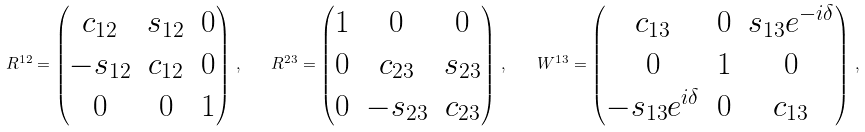Convert formula to latex. <formula><loc_0><loc_0><loc_500><loc_500>R ^ { 1 2 } = \begin{pmatrix} c _ { 1 2 } & s _ { 1 2 } & 0 \\ - s _ { 1 2 } & c _ { 1 2 } & 0 \\ 0 & 0 & 1 \end{pmatrix} \, , \quad R ^ { 2 3 } = \begin{pmatrix} 1 & 0 & 0 \\ 0 & c _ { 2 3 } & s _ { 2 3 } \\ 0 & - s _ { 2 3 } & c _ { 2 3 } \end{pmatrix} \, , \quad W ^ { 1 3 } = \begin{pmatrix} c _ { 1 3 } & 0 & s _ { 1 3 } e ^ { - i \delta } \\ 0 & 1 & 0 \\ - s _ { 1 3 } e ^ { i \delta } & 0 & c _ { 1 3 } \end{pmatrix} \, ,</formula> 